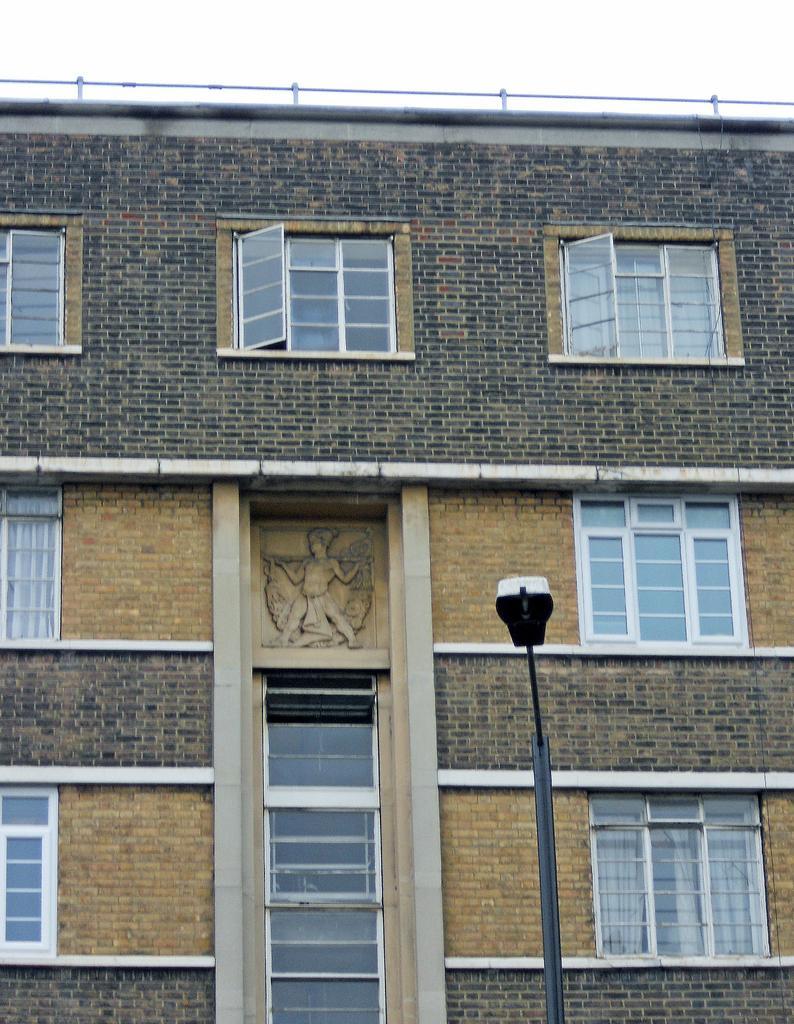Can you describe this image briefly? In this picture I can see the building. In the bottom right there is a street light. On the building there is a statue which is placed near to the windows. At the top I can see the sky and clouds. 